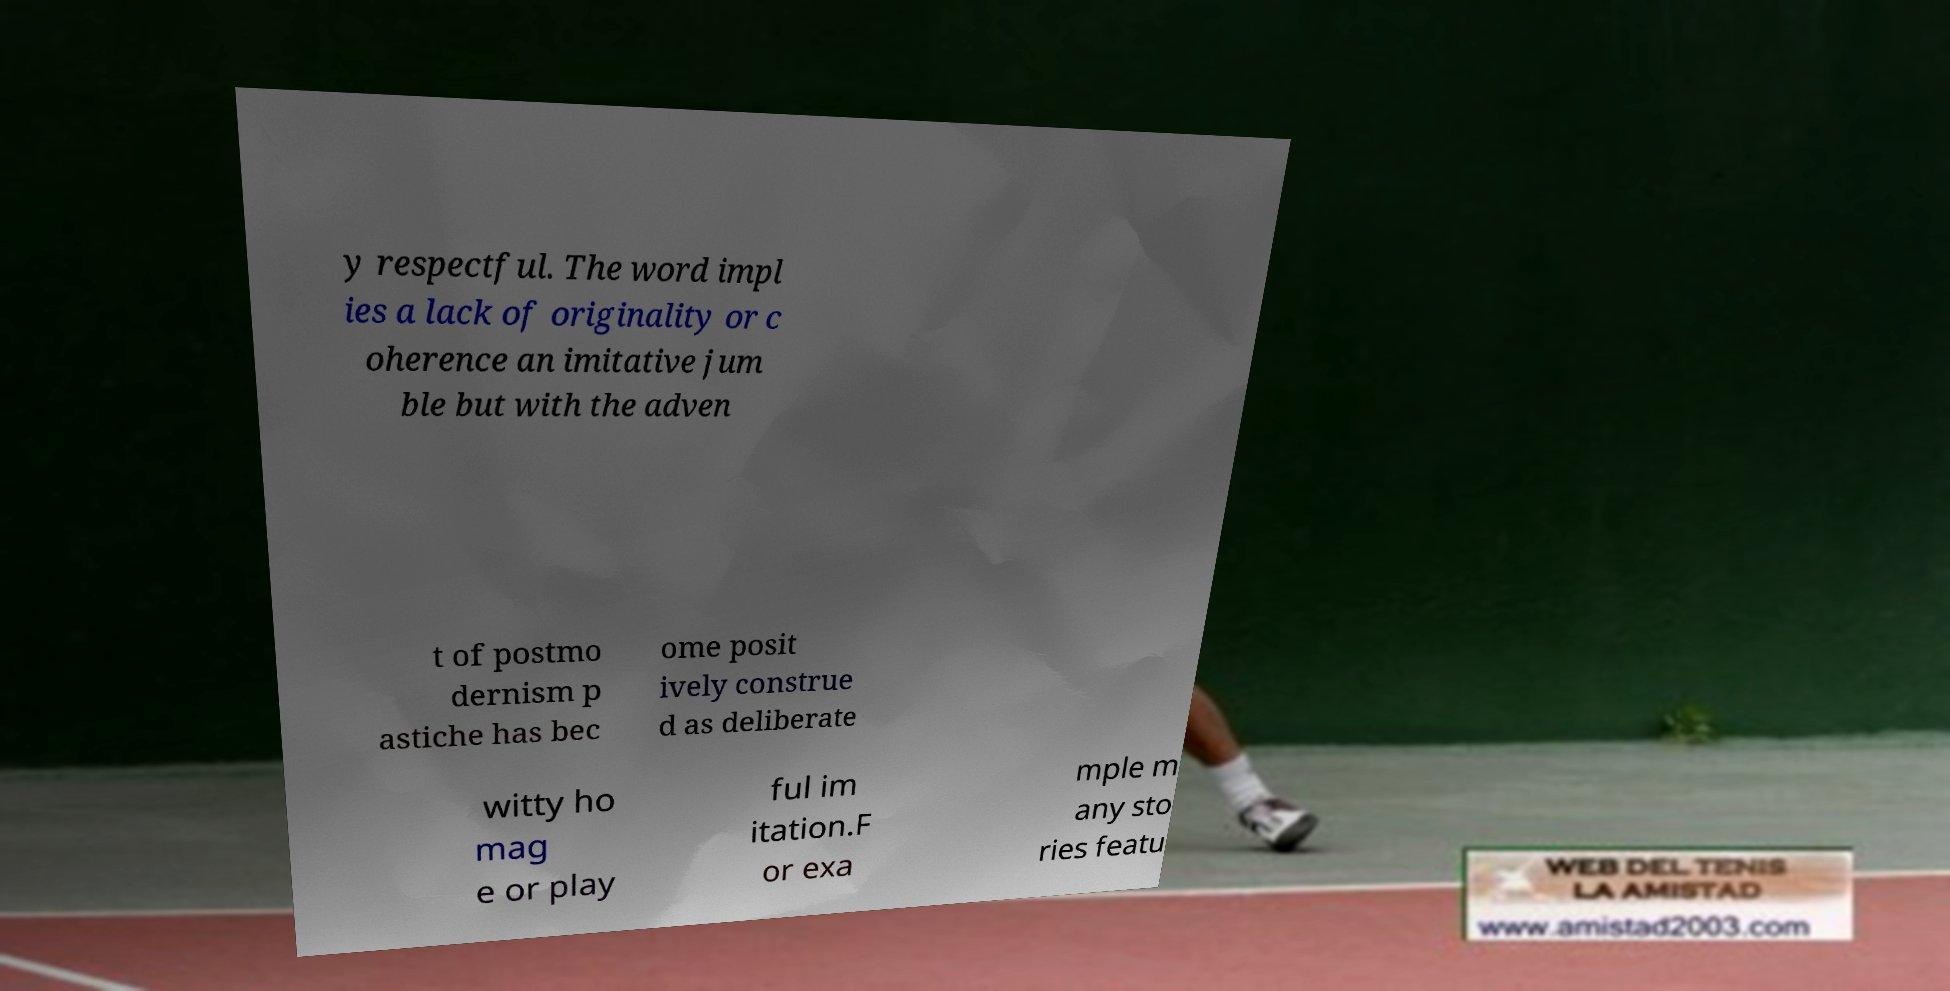Can you accurately transcribe the text from the provided image for me? y respectful. The word impl ies a lack of originality or c oherence an imitative jum ble but with the adven t of postmo dernism p astiche has bec ome posit ively construe d as deliberate witty ho mag e or play ful im itation.F or exa mple m any sto ries featu 